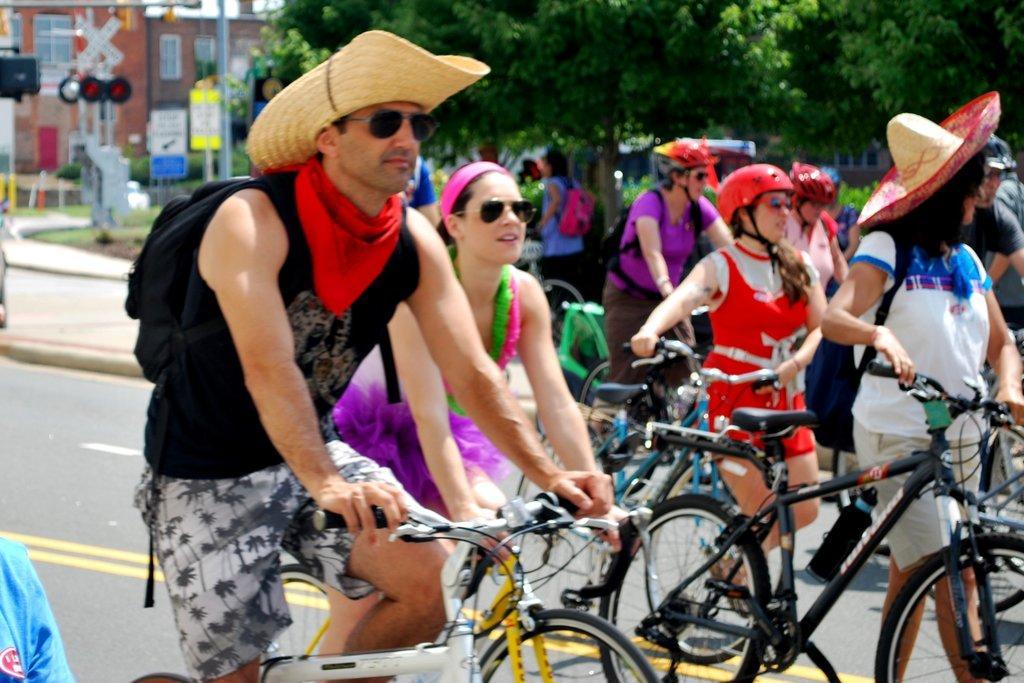Describe this image in one or two sentences. In this image I can see the group of people with the bicycles. I can see few people are wearing the hats and helmets. In the background I can see few more people, many trees, poles, boards and the buildings. 